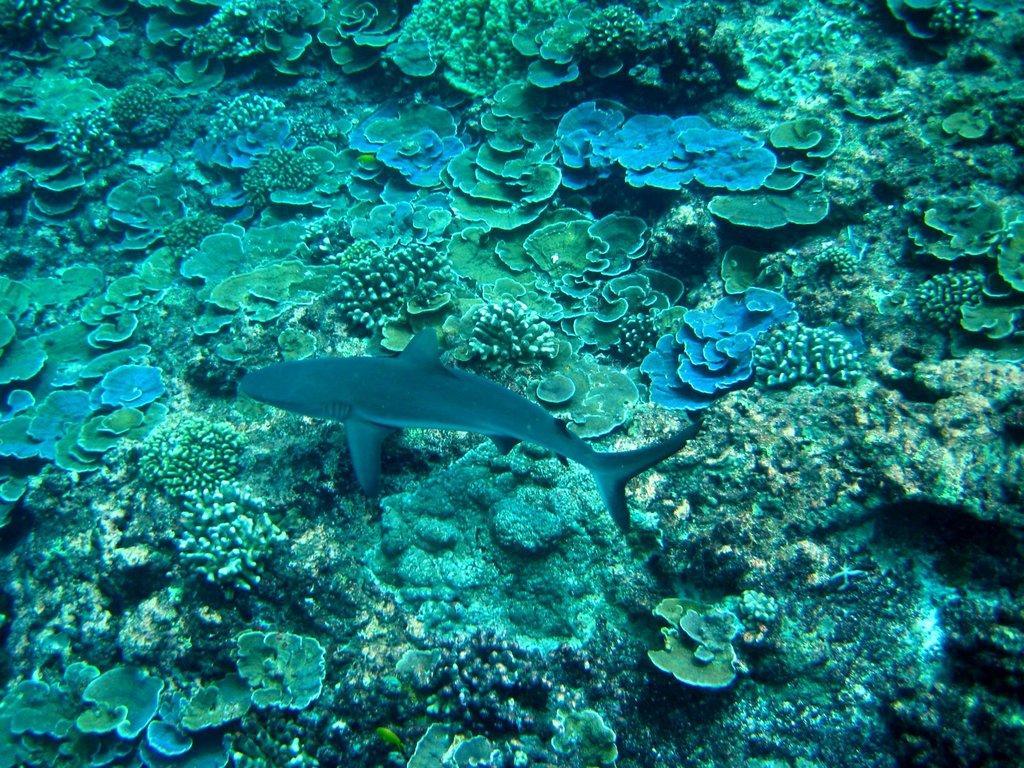Please provide a concise description of this image. In this image we can see fish in the water, we can also see some coral reef. 